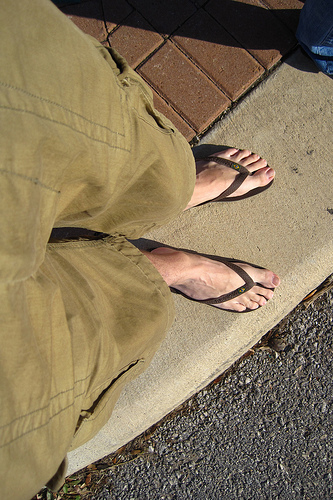<image>
Can you confirm if the road is under the man? Yes. The road is positioned underneath the man, with the man above it in the vertical space. 